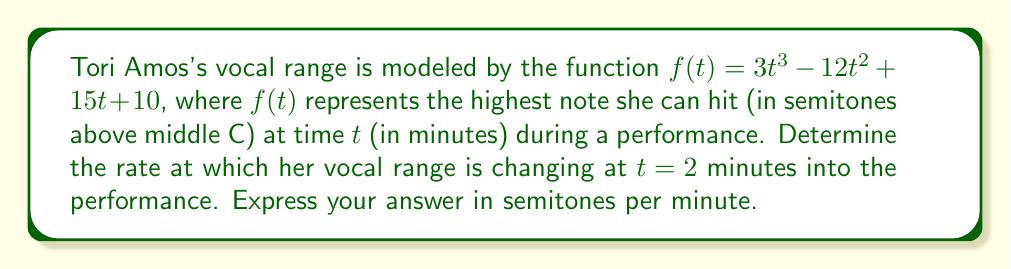Help me with this question. To solve this problem, we need to find the derivative of the given function and evaluate it at $t = 2$. This will give us the instantaneous rate of change of Tori's vocal range at that moment.

1. Given function: $f(t) = 3t^3 - 12t^2 + 15t + 10$

2. Find the derivative $f'(t)$ using the power rule:
   $$f'(t) = 9t^2 - 24t + 15$$

3. Evaluate $f'(t)$ at $t = 2$:
   $$f'(2) = 9(2)^2 - 24(2) + 15$$
   $$f'(2) = 9(4) - 48 + 15$$
   $$f'(2) = 36 - 48 + 15$$
   $$f'(2) = 3$$

The result, 3 semitones per minute, represents the rate at which Tori's vocal range is changing at $t = 2$ minutes into the performance. A positive value indicates that her range is increasing at that moment.
Answer: 3 semitones per minute 